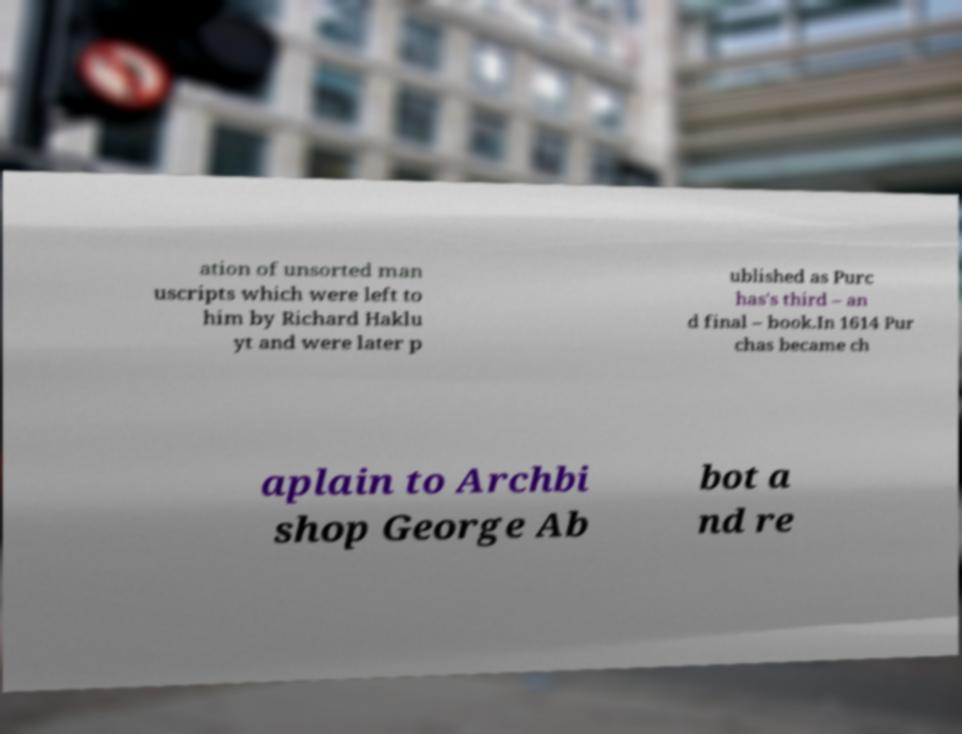Please read and relay the text visible in this image. What does it say? ation of unsorted man uscripts which were left to him by Richard Haklu yt and were later p ublished as Purc has's third – an d final – book.In 1614 Pur chas became ch aplain to Archbi shop George Ab bot a nd re 